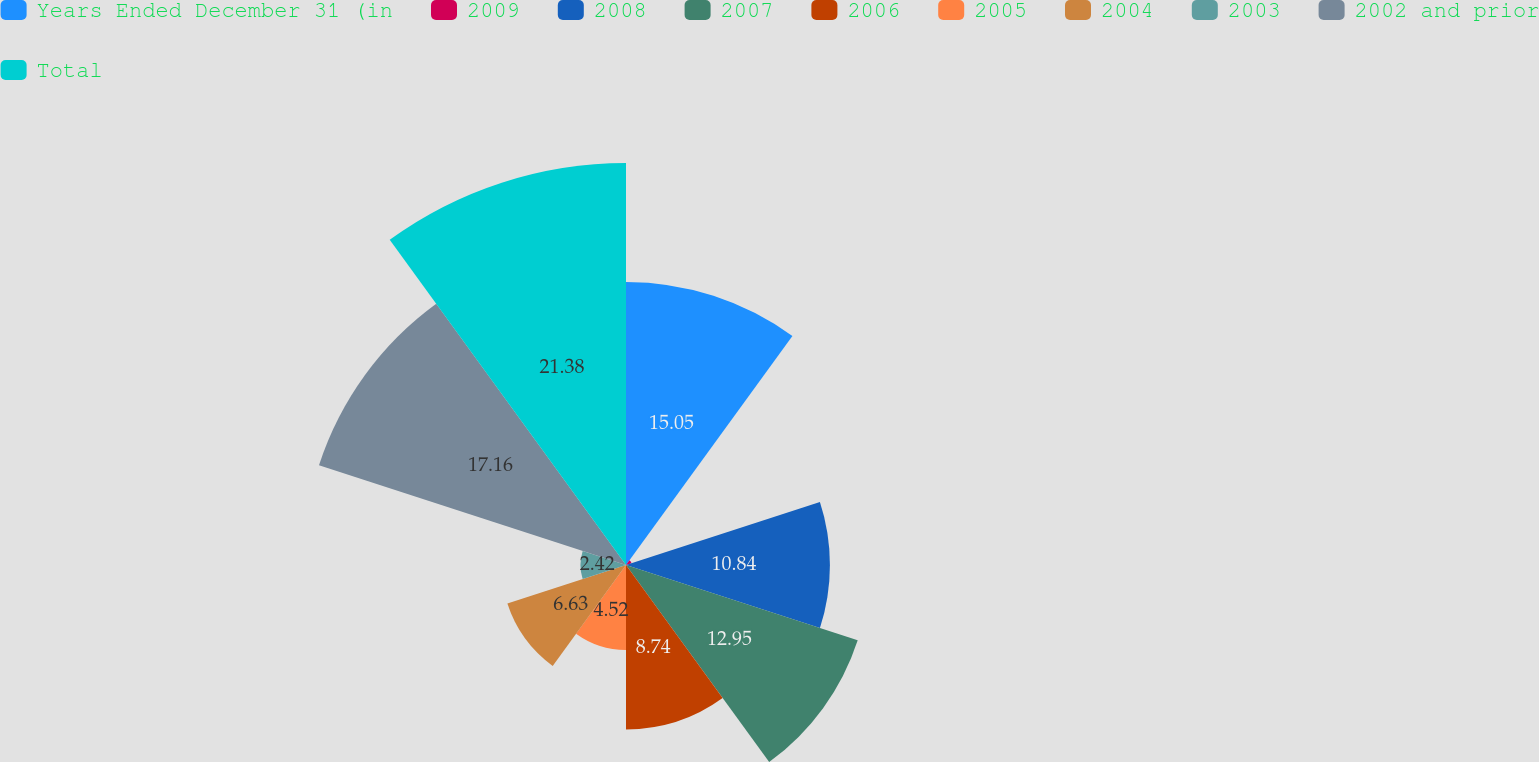<chart> <loc_0><loc_0><loc_500><loc_500><pie_chart><fcel>Years Ended December 31 (in<fcel>2009<fcel>2008<fcel>2007<fcel>2006<fcel>2005<fcel>2004<fcel>2003<fcel>2002 and prior<fcel>Total<nl><fcel>15.05%<fcel>0.31%<fcel>10.84%<fcel>12.95%<fcel>8.74%<fcel>4.52%<fcel>6.63%<fcel>2.42%<fcel>17.16%<fcel>21.37%<nl></chart> 